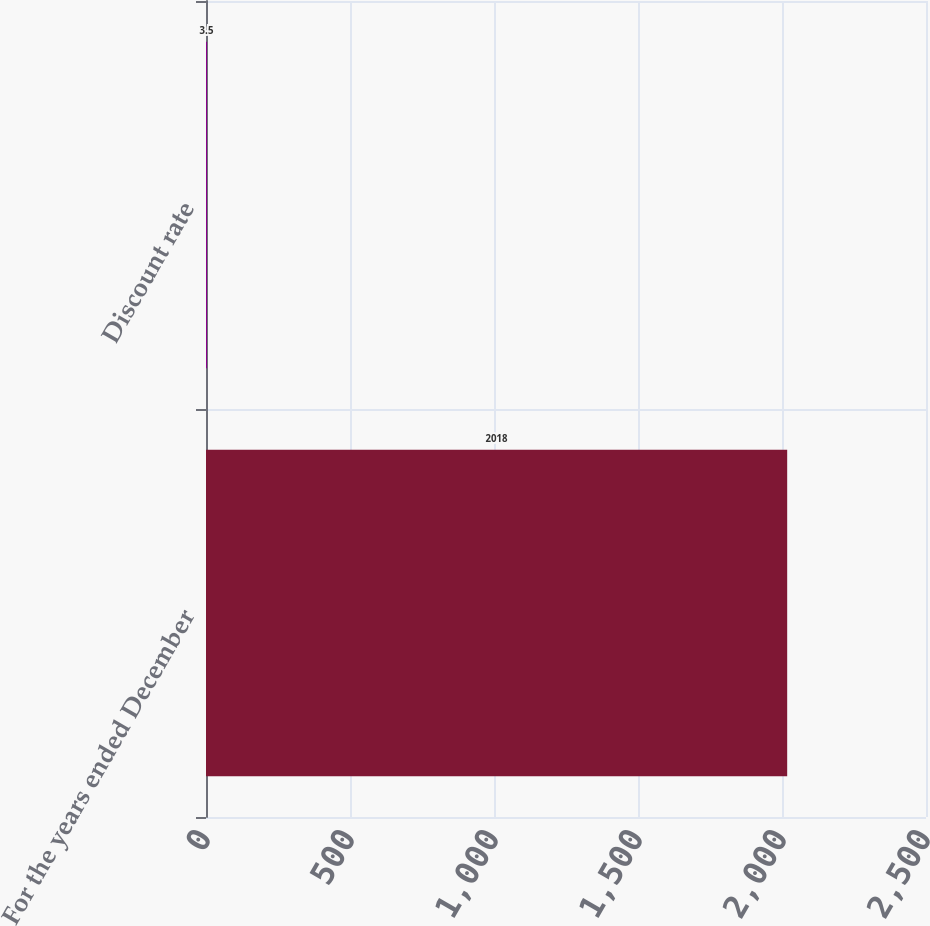Convert chart to OTSL. <chart><loc_0><loc_0><loc_500><loc_500><bar_chart><fcel>For the years ended December<fcel>Discount rate<nl><fcel>2018<fcel>3.5<nl></chart> 